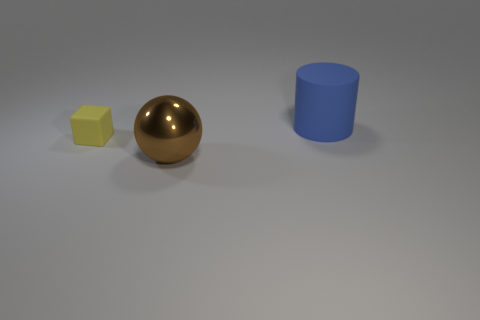Subtract all spheres. How many objects are left? 2 Subtract 1 blocks. How many blocks are left? 0 Add 2 large brown metal balls. How many objects exist? 5 Subtract 0 green spheres. How many objects are left? 3 Subtract all cyan cylinders. Subtract all cyan blocks. How many cylinders are left? 1 Subtract all yellow balls. How many yellow cylinders are left? 0 Subtract all matte cubes. Subtract all blue rubber objects. How many objects are left? 1 Add 3 balls. How many balls are left? 4 Add 1 tiny blocks. How many tiny blocks exist? 2 